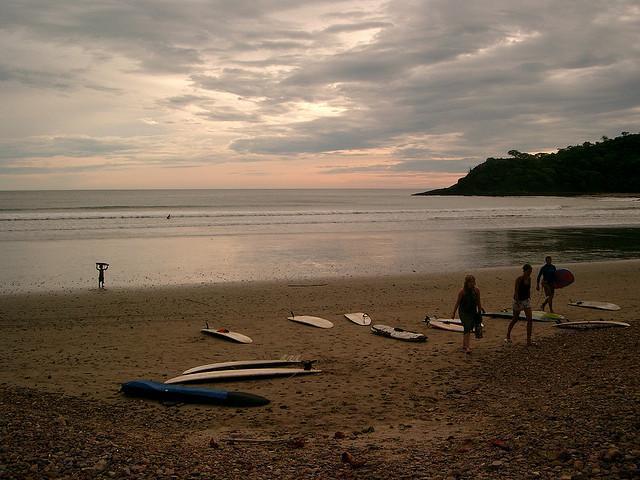Why is he carrying his surfboard?
Choose the right answer and clarify with the format: 'Answer: answer
Rationale: rationale.'
Options: Stealing it, exercise, done surfing, hiding it. Answer: done surfing.
Rationale: The man is done surfing. 